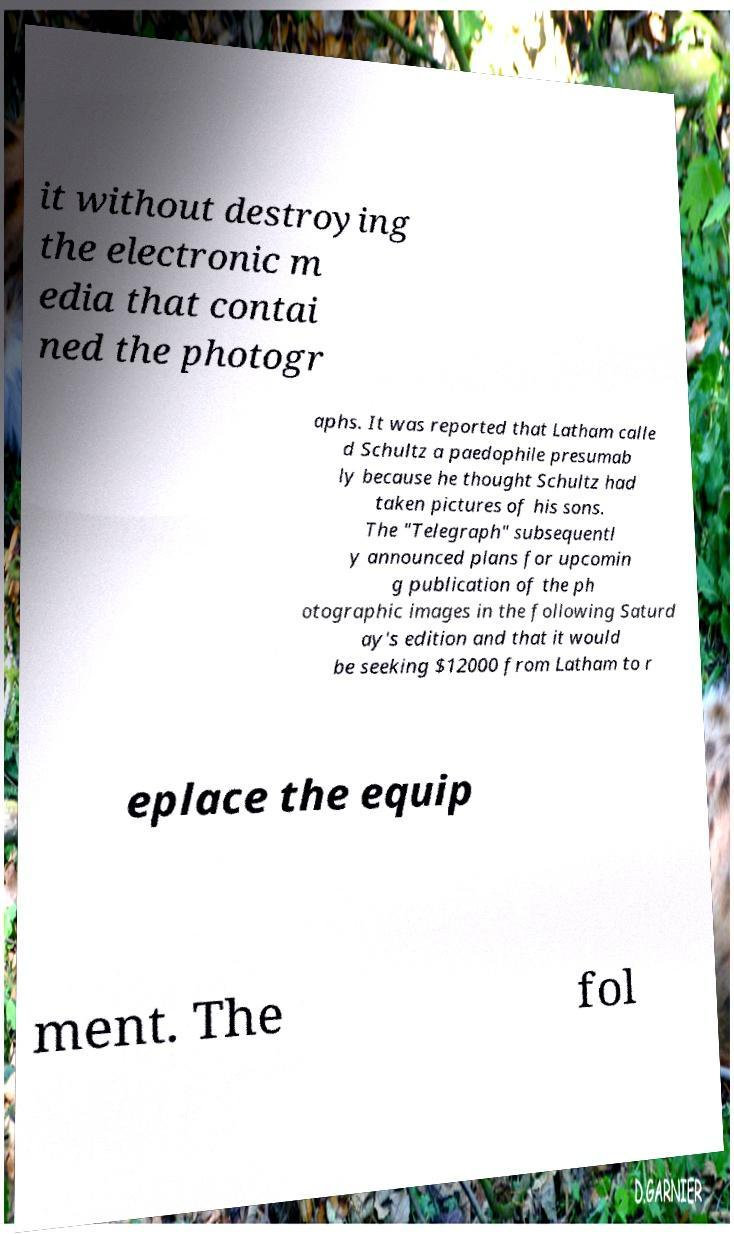I need the written content from this picture converted into text. Can you do that? it without destroying the electronic m edia that contai ned the photogr aphs. It was reported that Latham calle d Schultz a paedophile presumab ly because he thought Schultz had taken pictures of his sons. The "Telegraph" subsequentl y announced plans for upcomin g publication of the ph otographic images in the following Saturd ay's edition and that it would be seeking $12000 from Latham to r eplace the equip ment. The fol 